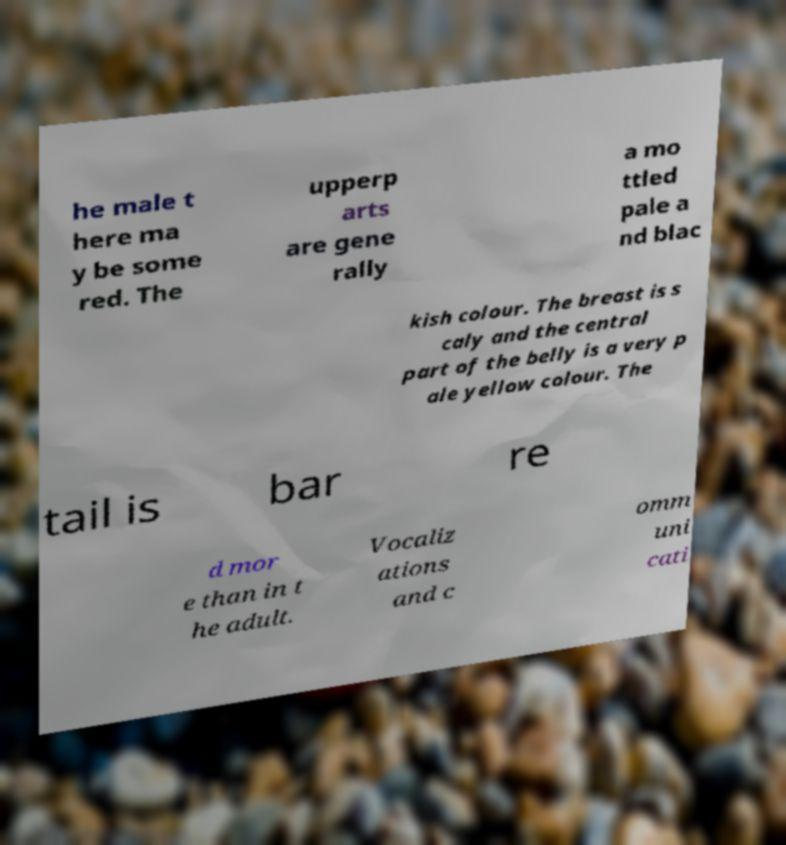I need the written content from this picture converted into text. Can you do that? he male t here ma y be some red. The upperp arts are gene rally a mo ttled pale a nd blac kish colour. The breast is s caly and the central part of the belly is a very p ale yellow colour. The tail is bar re d mor e than in t he adult. Vocaliz ations and c omm uni cati 